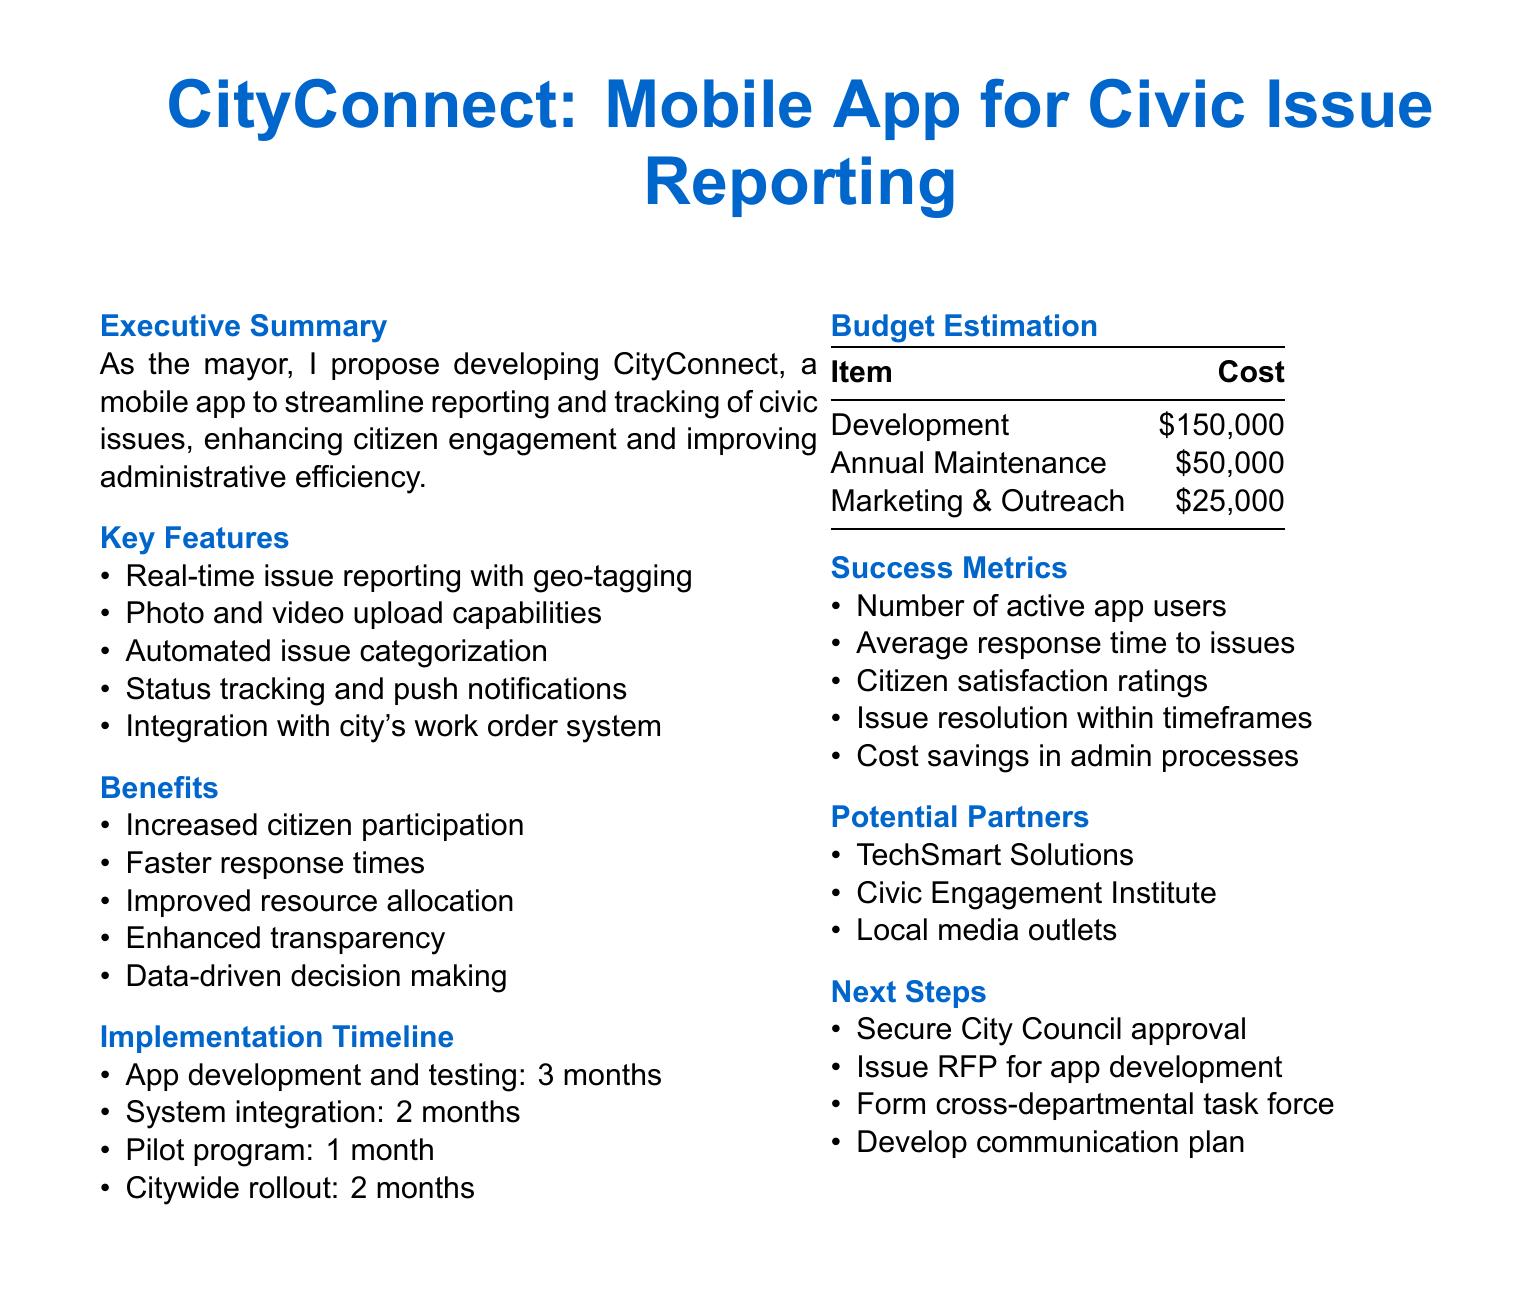what is the name of the mobile app? The name of the mobile app proposed in the document is CityConnect.
Answer: CityConnect what is the total cost for the development of the app? The total cost for the app development is explicitly stated in the budget estimation section.
Answer: $150,000 how long will the app development and testing take? The document specifies a timeline for app development and testing.
Answer: 3 months what is the estimated annual maintenance cost? The document provides the annual maintenance cost in the budget estimation.
Answer: $50,000 what are the key features of the app? The document lists several key features designed for the app's functionality.
Answer: Real-time issue reporting with geo-tagging how many months will the pilot program last? The timeline section of the document outlines the duration of the pilot program.
Answer: 1 month how will the success of the app be measured? The document outlines specific metrics that will be used to assess success.
Answer: Number of active app users what is one potential partner mentioned in the document? The document lists potential partners that may collaborate on the project.
Answer: TechSmart Solutions what is a benefit of the mobile app for citizens? The benefits section details how the app will enhance the civic engagement experience.
Answer: Increased citizen participation 